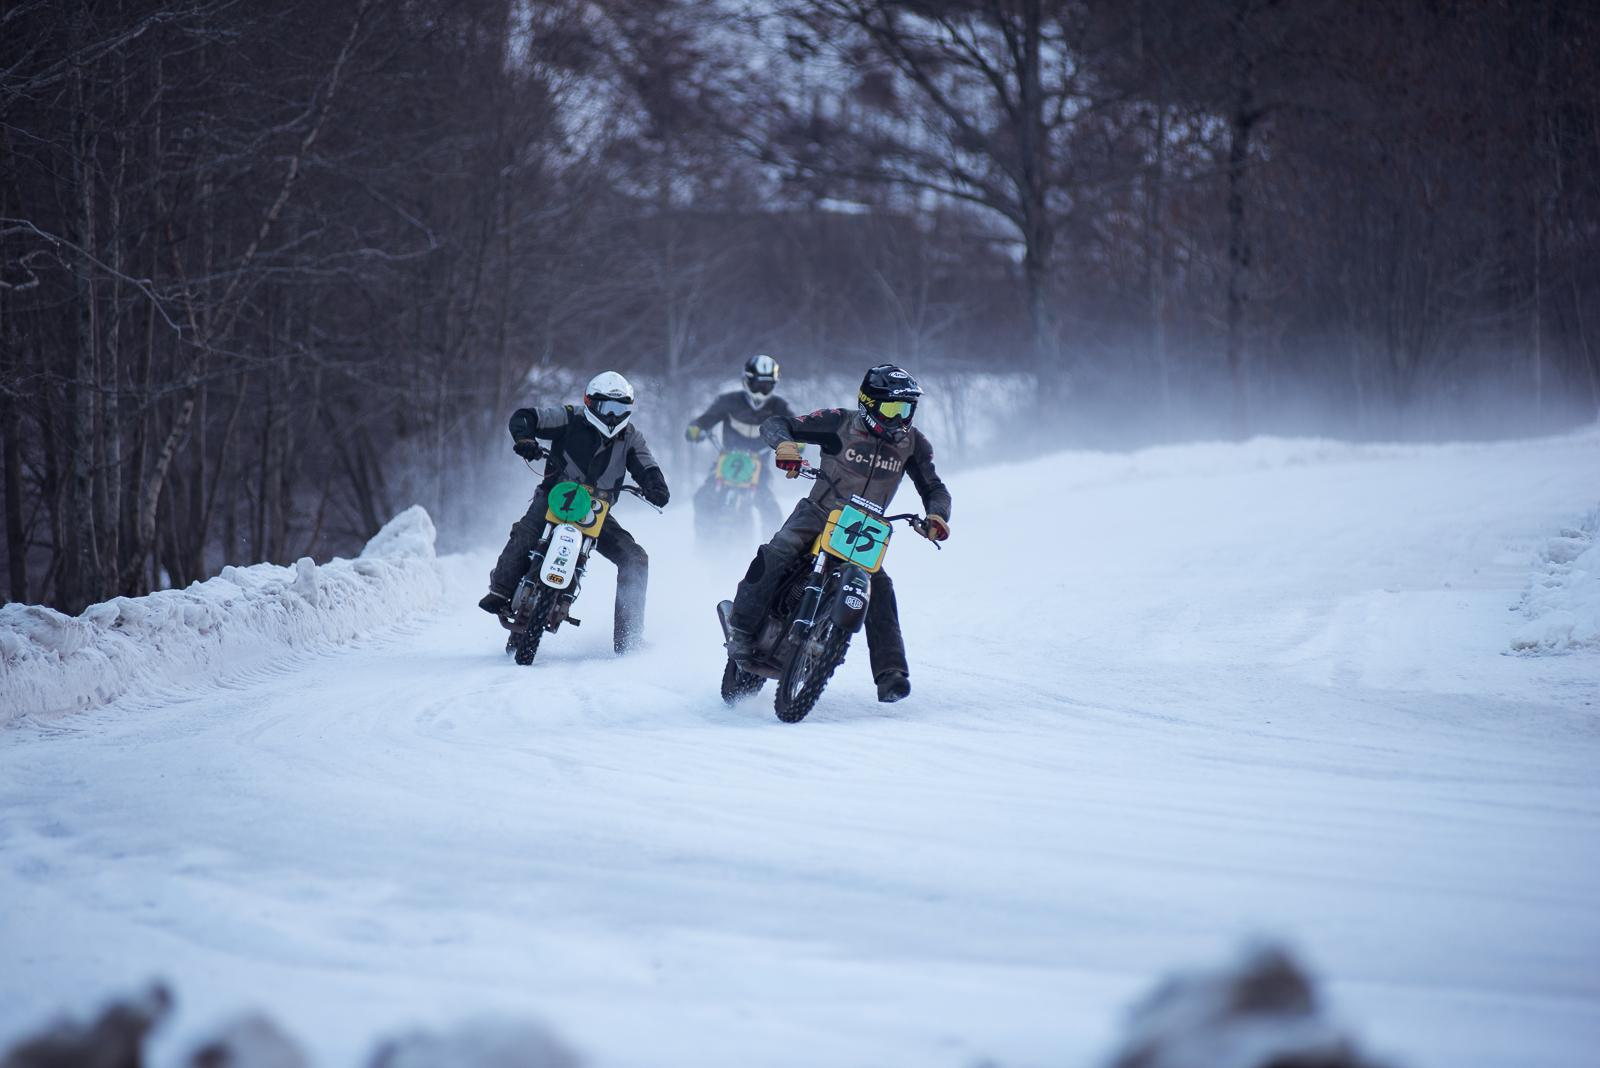What might be the challenges in riding motorbikes in these conditions? Riding motorbikes on snow presents various challenges, such as reduced traction, handling difficulties due to the slippery surface, and the need for precise throttle control. Riders must also manage visibility issues caused by snowfall and the extra physical exertion required to balance and control the bike. 